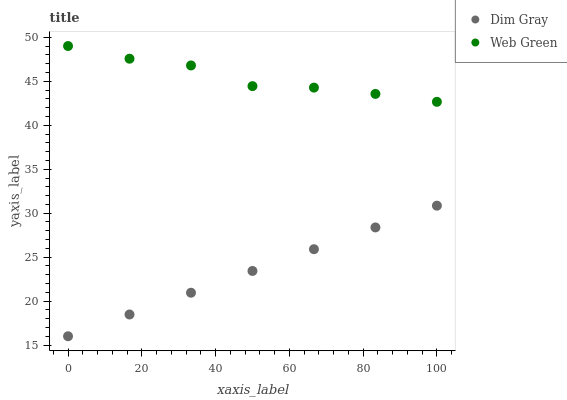Does Dim Gray have the minimum area under the curve?
Answer yes or no. Yes. Does Web Green have the maximum area under the curve?
Answer yes or no. Yes. Does Web Green have the minimum area under the curve?
Answer yes or no. No. Is Dim Gray the smoothest?
Answer yes or no. Yes. Is Web Green the roughest?
Answer yes or no. Yes. Is Web Green the smoothest?
Answer yes or no. No. Does Dim Gray have the lowest value?
Answer yes or no. Yes. Does Web Green have the lowest value?
Answer yes or no. No. Does Web Green have the highest value?
Answer yes or no. Yes. Is Dim Gray less than Web Green?
Answer yes or no. Yes. Is Web Green greater than Dim Gray?
Answer yes or no. Yes. Does Dim Gray intersect Web Green?
Answer yes or no. No. 